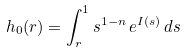<formula> <loc_0><loc_0><loc_500><loc_500>h _ { 0 } ( r ) = \int _ { r } ^ { 1 } s ^ { 1 - n } \, e ^ { I ( s ) } \, d s</formula> 